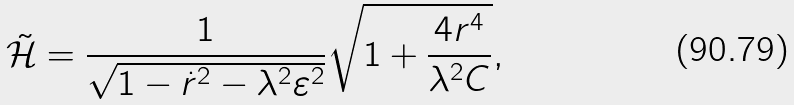Convert formula to latex. <formula><loc_0><loc_0><loc_500><loc_500>\tilde { \mathcal { H } } = \frac { 1 } { \sqrt { 1 - \dot { r } ^ { 2 } - \lambda ^ { 2 } \varepsilon ^ { 2 } } } \sqrt { 1 + \frac { 4 r ^ { 4 } } { \lambda ^ { 2 } C } } ,</formula> 